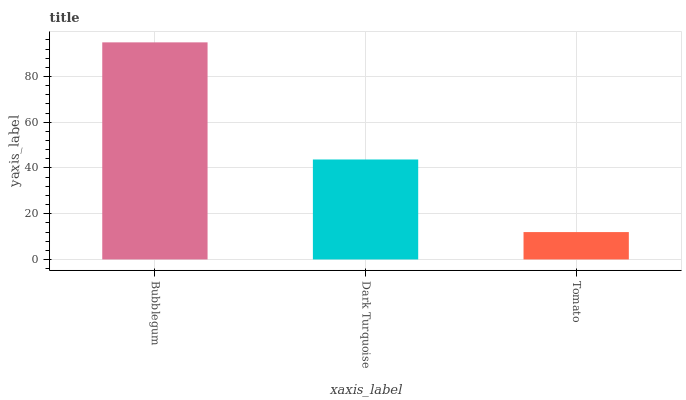Is Dark Turquoise the minimum?
Answer yes or no. No. Is Dark Turquoise the maximum?
Answer yes or no. No. Is Bubblegum greater than Dark Turquoise?
Answer yes or no. Yes. Is Dark Turquoise less than Bubblegum?
Answer yes or no. Yes. Is Dark Turquoise greater than Bubblegum?
Answer yes or no. No. Is Bubblegum less than Dark Turquoise?
Answer yes or no. No. Is Dark Turquoise the high median?
Answer yes or no. Yes. Is Dark Turquoise the low median?
Answer yes or no. Yes. Is Bubblegum the high median?
Answer yes or no. No. Is Tomato the low median?
Answer yes or no. No. 